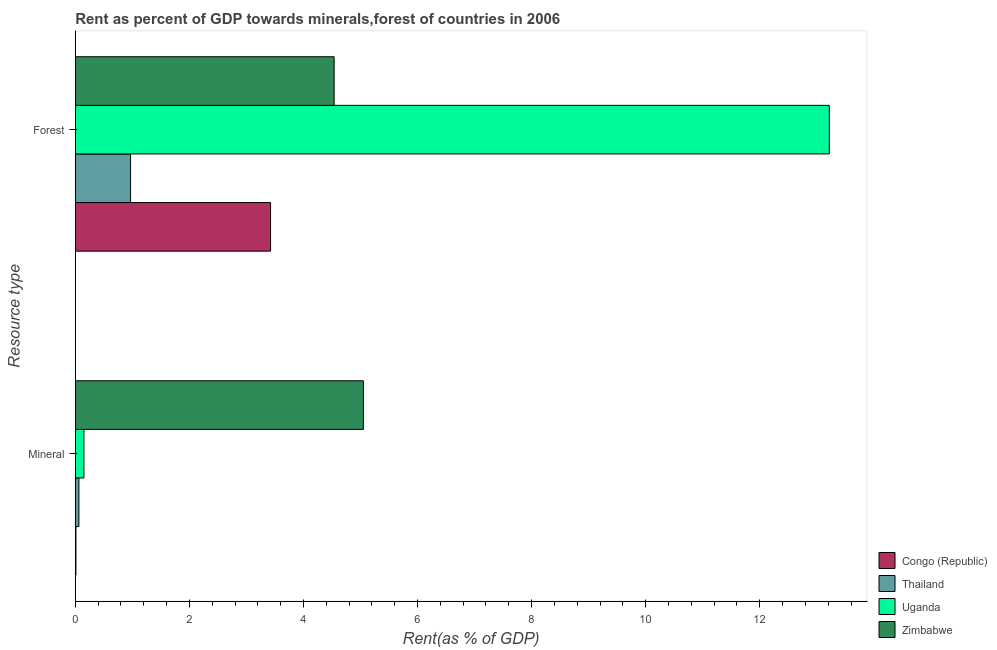How many different coloured bars are there?
Your answer should be compact. 4. Are the number of bars on each tick of the Y-axis equal?
Your response must be concise. Yes. How many bars are there on the 1st tick from the top?
Ensure brevity in your answer.  4. What is the label of the 1st group of bars from the top?
Offer a terse response. Forest. What is the mineral rent in Congo (Republic)?
Provide a short and direct response. 0.01. Across all countries, what is the maximum forest rent?
Your response must be concise. 13.22. Across all countries, what is the minimum forest rent?
Provide a succinct answer. 0.97. In which country was the forest rent maximum?
Offer a very short reply. Uganda. In which country was the mineral rent minimum?
Give a very brief answer. Congo (Republic). What is the total mineral rent in the graph?
Provide a succinct answer. 5.28. What is the difference between the forest rent in Uganda and that in Thailand?
Your answer should be compact. 12.25. What is the difference between the forest rent in Uganda and the mineral rent in Zimbabwe?
Give a very brief answer. 8.17. What is the average forest rent per country?
Your response must be concise. 5.54. What is the difference between the forest rent and mineral rent in Congo (Republic)?
Keep it short and to the point. 3.41. In how many countries, is the forest rent greater than 5.6 %?
Offer a very short reply. 1. What is the ratio of the forest rent in Thailand to that in Zimbabwe?
Provide a succinct answer. 0.21. In how many countries, is the forest rent greater than the average forest rent taken over all countries?
Provide a succinct answer. 1. What does the 2nd bar from the top in Forest represents?
Give a very brief answer. Uganda. What does the 2nd bar from the bottom in Mineral represents?
Provide a short and direct response. Thailand. How many countries are there in the graph?
Offer a very short reply. 4. Are the values on the major ticks of X-axis written in scientific E-notation?
Provide a short and direct response. No. Does the graph contain any zero values?
Ensure brevity in your answer.  No. Does the graph contain grids?
Give a very brief answer. No. Where does the legend appear in the graph?
Provide a succinct answer. Bottom right. What is the title of the graph?
Give a very brief answer. Rent as percent of GDP towards minerals,forest of countries in 2006. What is the label or title of the X-axis?
Make the answer very short. Rent(as % of GDP). What is the label or title of the Y-axis?
Provide a short and direct response. Resource type. What is the Rent(as % of GDP) of Congo (Republic) in Mineral?
Your answer should be very brief. 0.01. What is the Rent(as % of GDP) of Thailand in Mineral?
Give a very brief answer. 0.06. What is the Rent(as % of GDP) of Uganda in Mineral?
Your response must be concise. 0.15. What is the Rent(as % of GDP) in Zimbabwe in Mineral?
Your answer should be compact. 5.05. What is the Rent(as % of GDP) in Congo (Republic) in Forest?
Your answer should be compact. 3.42. What is the Rent(as % of GDP) in Thailand in Forest?
Provide a short and direct response. 0.97. What is the Rent(as % of GDP) in Uganda in Forest?
Your answer should be very brief. 13.22. What is the Rent(as % of GDP) of Zimbabwe in Forest?
Your response must be concise. 4.54. Across all Resource type, what is the maximum Rent(as % of GDP) in Congo (Republic)?
Provide a succinct answer. 3.42. Across all Resource type, what is the maximum Rent(as % of GDP) in Thailand?
Your answer should be very brief. 0.97. Across all Resource type, what is the maximum Rent(as % of GDP) in Uganda?
Your answer should be very brief. 13.22. Across all Resource type, what is the maximum Rent(as % of GDP) of Zimbabwe?
Provide a short and direct response. 5.05. Across all Resource type, what is the minimum Rent(as % of GDP) in Congo (Republic)?
Your response must be concise. 0.01. Across all Resource type, what is the minimum Rent(as % of GDP) in Thailand?
Your answer should be very brief. 0.06. Across all Resource type, what is the minimum Rent(as % of GDP) in Uganda?
Your answer should be compact. 0.15. Across all Resource type, what is the minimum Rent(as % of GDP) in Zimbabwe?
Offer a terse response. 4.54. What is the total Rent(as % of GDP) of Congo (Republic) in the graph?
Offer a terse response. 3.43. What is the total Rent(as % of GDP) of Thailand in the graph?
Provide a succinct answer. 1.03. What is the total Rent(as % of GDP) in Uganda in the graph?
Provide a succinct answer. 13.37. What is the total Rent(as % of GDP) in Zimbabwe in the graph?
Ensure brevity in your answer.  9.59. What is the difference between the Rent(as % of GDP) of Congo (Republic) in Mineral and that in Forest?
Ensure brevity in your answer.  -3.41. What is the difference between the Rent(as % of GDP) in Thailand in Mineral and that in Forest?
Give a very brief answer. -0.91. What is the difference between the Rent(as % of GDP) in Uganda in Mineral and that in Forest?
Your response must be concise. -13.07. What is the difference between the Rent(as % of GDP) in Zimbabwe in Mineral and that in Forest?
Give a very brief answer. 0.51. What is the difference between the Rent(as % of GDP) in Congo (Republic) in Mineral and the Rent(as % of GDP) in Thailand in Forest?
Your answer should be very brief. -0.96. What is the difference between the Rent(as % of GDP) of Congo (Republic) in Mineral and the Rent(as % of GDP) of Uganda in Forest?
Ensure brevity in your answer.  -13.21. What is the difference between the Rent(as % of GDP) in Congo (Republic) in Mineral and the Rent(as % of GDP) in Zimbabwe in Forest?
Offer a very short reply. -4.53. What is the difference between the Rent(as % of GDP) in Thailand in Mineral and the Rent(as % of GDP) in Uganda in Forest?
Your answer should be very brief. -13.16. What is the difference between the Rent(as % of GDP) of Thailand in Mineral and the Rent(as % of GDP) of Zimbabwe in Forest?
Ensure brevity in your answer.  -4.47. What is the difference between the Rent(as % of GDP) in Uganda in Mineral and the Rent(as % of GDP) in Zimbabwe in Forest?
Provide a succinct answer. -4.39. What is the average Rent(as % of GDP) of Congo (Republic) per Resource type?
Your answer should be compact. 1.72. What is the average Rent(as % of GDP) of Thailand per Resource type?
Your response must be concise. 0.52. What is the average Rent(as % of GDP) in Uganda per Resource type?
Offer a very short reply. 6.69. What is the average Rent(as % of GDP) in Zimbabwe per Resource type?
Your answer should be very brief. 4.79. What is the difference between the Rent(as % of GDP) in Congo (Republic) and Rent(as % of GDP) in Thailand in Mineral?
Give a very brief answer. -0.05. What is the difference between the Rent(as % of GDP) of Congo (Republic) and Rent(as % of GDP) of Uganda in Mineral?
Provide a succinct answer. -0.14. What is the difference between the Rent(as % of GDP) in Congo (Republic) and Rent(as % of GDP) in Zimbabwe in Mineral?
Provide a short and direct response. -5.04. What is the difference between the Rent(as % of GDP) of Thailand and Rent(as % of GDP) of Uganda in Mineral?
Offer a terse response. -0.09. What is the difference between the Rent(as % of GDP) in Thailand and Rent(as % of GDP) in Zimbabwe in Mineral?
Ensure brevity in your answer.  -4.99. What is the difference between the Rent(as % of GDP) in Uganda and Rent(as % of GDP) in Zimbabwe in Mineral?
Keep it short and to the point. -4.9. What is the difference between the Rent(as % of GDP) of Congo (Republic) and Rent(as % of GDP) of Thailand in Forest?
Your answer should be very brief. 2.45. What is the difference between the Rent(as % of GDP) in Congo (Republic) and Rent(as % of GDP) in Uganda in Forest?
Ensure brevity in your answer.  -9.8. What is the difference between the Rent(as % of GDP) in Congo (Republic) and Rent(as % of GDP) in Zimbabwe in Forest?
Provide a short and direct response. -1.11. What is the difference between the Rent(as % of GDP) of Thailand and Rent(as % of GDP) of Uganda in Forest?
Keep it short and to the point. -12.25. What is the difference between the Rent(as % of GDP) in Thailand and Rent(as % of GDP) in Zimbabwe in Forest?
Provide a short and direct response. -3.57. What is the difference between the Rent(as % of GDP) in Uganda and Rent(as % of GDP) in Zimbabwe in Forest?
Make the answer very short. 8.68. What is the ratio of the Rent(as % of GDP) of Congo (Republic) in Mineral to that in Forest?
Give a very brief answer. 0. What is the ratio of the Rent(as % of GDP) in Thailand in Mineral to that in Forest?
Ensure brevity in your answer.  0.07. What is the ratio of the Rent(as % of GDP) in Uganda in Mineral to that in Forest?
Offer a very short reply. 0.01. What is the ratio of the Rent(as % of GDP) in Zimbabwe in Mineral to that in Forest?
Your response must be concise. 1.11. What is the difference between the highest and the second highest Rent(as % of GDP) of Congo (Republic)?
Keep it short and to the point. 3.41. What is the difference between the highest and the second highest Rent(as % of GDP) in Thailand?
Your answer should be very brief. 0.91. What is the difference between the highest and the second highest Rent(as % of GDP) of Uganda?
Give a very brief answer. 13.07. What is the difference between the highest and the second highest Rent(as % of GDP) in Zimbabwe?
Your answer should be very brief. 0.51. What is the difference between the highest and the lowest Rent(as % of GDP) in Congo (Republic)?
Give a very brief answer. 3.41. What is the difference between the highest and the lowest Rent(as % of GDP) of Thailand?
Ensure brevity in your answer.  0.91. What is the difference between the highest and the lowest Rent(as % of GDP) in Uganda?
Provide a succinct answer. 13.07. What is the difference between the highest and the lowest Rent(as % of GDP) of Zimbabwe?
Your answer should be compact. 0.51. 